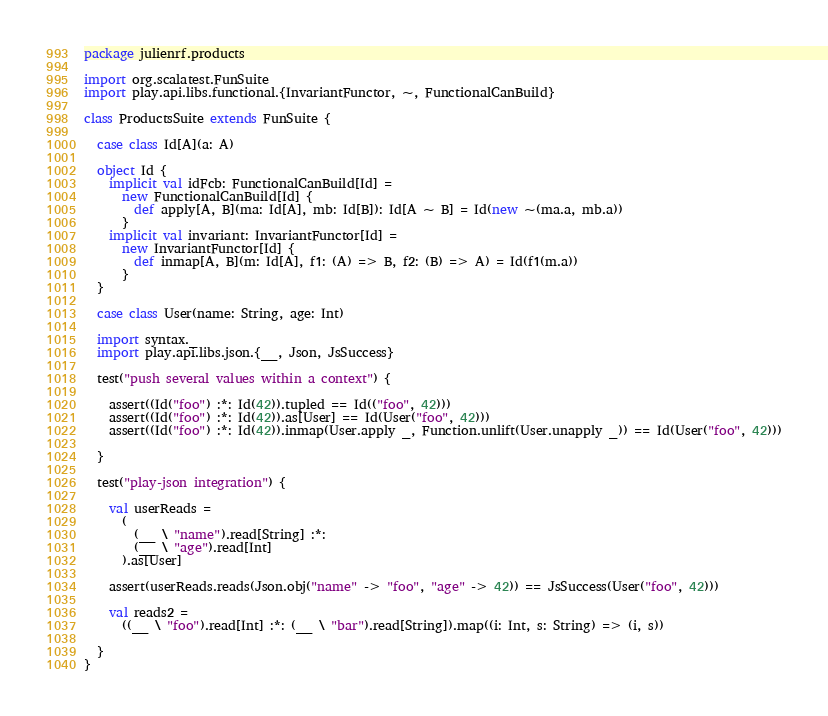Convert code to text. <code><loc_0><loc_0><loc_500><loc_500><_Scala_>package julienrf.products

import org.scalatest.FunSuite
import play.api.libs.functional.{InvariantFunctor, ~, FunctionalCanBuild}

class ProductsSuite extends FunSuite {

  case class Id[A](a: A)

  object Id {
    implicit val idFcb: FunctionalCanBuild[Id] =
      new FunctionalCanBuild[Id] {
        def apply[A, B](ma: Id[A], mb: Id[B]): Id[A ~ B] = Id(new ~(ma.a, mb.a))
      }
    implicit val invariant: InvariantFunctor[Id] =
      new InvariantFunctor[Id] {
        def inmap[A, B](m: Id[A], f1: (A) => B, f2: (B) => A) = Id(f1(m.a))
      }
  }

  case class User(name: String, age: Int)

  import syntax._
  import play.api.libs.json.{__, Json, JsSuccess}

  test("push several values within a context") {

    assert((Id("foo") :*: Id(42)).tupled == Id(("foo", 42)))
    assert((Id("foo") :*: Id(42)).as[User] == Id(User("foo", 42)))
    assert((Id("foo") :*: Id(42)).inmap(User.apply _, Function.unlift(User.unapply _)) == Id(User("foo", 42)))

  }

  test("play-json integration") {

    val userReads =
      (
        (__ \ "name").read[String] :*:
        (__ \ "age").read[Int]
      ).as[User]

    assert(userReads.reads(Json.obj("name" -> "foo", "age" -> 42)) == JsSuccess(User("foo", 42)))

    val reads2 =
      ((__ \ "foo").read[Int] :*: (__ \ "bar").read[String]).map((i: Int, s: String) => (i, s))

  }
}
</code> 